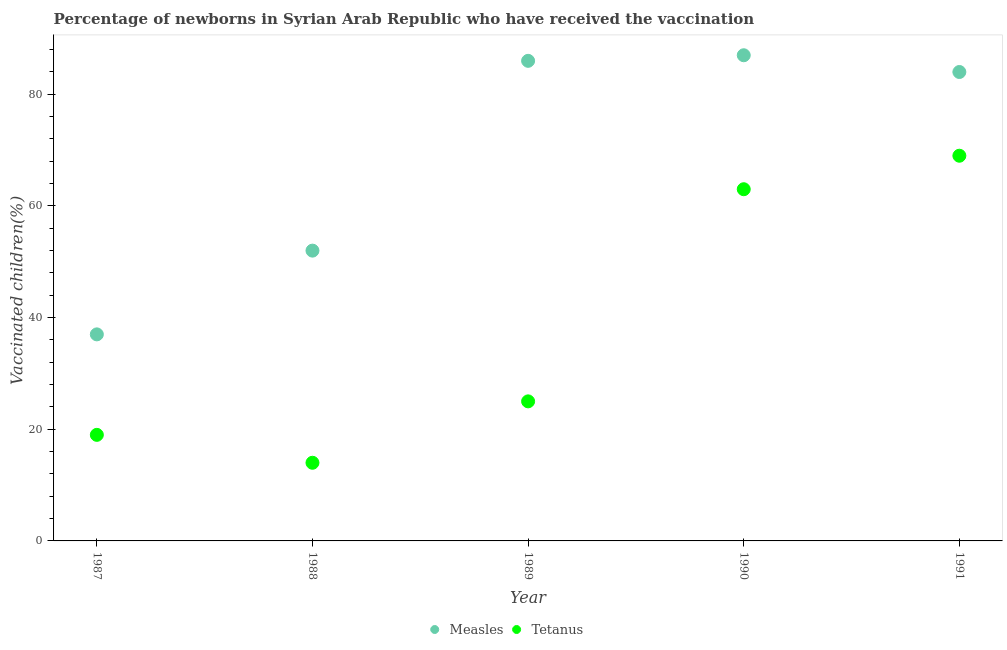Is the number of dotlines equal to the number of legend labels?
Make the answer very short. Yes. What is the percentage of newborns who received vaccination for tetanus in 1991?
Ensure brevity in your answer.  69. Across all years, what is the maximum percentage of newborns who received vaccination for measles?
Provide a succinct answer. 87. Across all years, what is the minimum percentage of newborns who received vaccination for tetanus?
Keep it short and to the point. 14. In which year was the percentage of newborns who received vaccination for measles maximum?
Give a very brief answer. 1990. In which year was the percentage of newborns who received vaccination for tetanus minimum?
Provide a short and direct response. 1988. What is the total percentage of newborns who received vaccination for tetanus in the graph?
Ensure brevity in your answer.  190. What is the difference between the percentage of newborns who received vaccination for measles in 1987 and that in 1990?
Provide a short and direct response. -50. What is the difference between the percentage of newborns who received vaccination for tetanus in 1988 and the percentage of newborns who received vaccination for measles in 1991?
Your answer should be compact. -70. What is the average percentage of newborns who received vaccination for measles per year?
Give a very brief answer. 69.2. In the year 1990, what is the difference between the percentage of newborns who received vaccination for tetanus and percentage of newborns who received vaccination for measles?
Give a very brief answer. -24. In how many years, is the percentage of newborns who received vaccination for tetanus greater than 32 %?
Your answer should be very brief. 2. What is the ratio of the percentage of newborns who received vaccination for measles in 1989 to that in 1991?
Your answer should be very brief. 1.02. Is the percentage of newborns who received vaccination for measles in 1987 less than that in 1988?
Your answer should be compact. Yes. What is the difference between the highest and the lowest percentage of newborns who received vaccination for tetanus?
Your response must be concise. 55. Does the percentage of newborns who received vaccination for tetanus monotonically increase over the years?
Provide a succinct answer. No. How many dotlines are there?
Offer a very short reply. 2. Does the graph contain any zero values?
Give a very brief answer. No. Does the graph contain grids?
Offer a very short reply. No. Where does the legend appear in the graph?
Your answer should be compact. Bottom center. What is the title of the graph?
Your answer should be compact. Percentage of newborns in Syrian Arab Republic who have received the vaccination. What is the label or title of the Y-axis?
Keep it short and to the point. Vaccinated children(%)
. What is the Vaccinated children(%)
 in Measles in 1987?
Your response must be concise. 37. What is the Vaccinated children(%)
 of Measles in 1988?
Provide a short and direct response. 52. What is the Vaccinated children(%)
 in Tetanus in 1988?
Keep it short and to the point. 14. What is the Vaccinated children(%)
 in Measles in 1989?
Keep it short and to the point. 86. What is the Vaccinated children(%)
 in Tetanus in 1989?
Offer a terse response. 25. What is the Vaccinated children(%)
 of Measles in 1990?
Your answer should be very brief. 87. What is the Vaccinated children(%)
 of Measles in 1991?
Offer a terse response. 84. What is the Vaccinated children(%)
 of Tetanus in 1991?
Offer a very short reply. 69. Across all years, what is the maximum Vaccinated children(%)
 of Measles?
Offer a terse response. 87. Across all years, what is the maximum Vaccinated children(%)
 of Tetanus?
Provide a short and direct response. 69. Across all years, what is the minimum Vaccinated children(%)
 of Measles?
Make the answer very short. 37. What is the total Vaccinated children(%)
 of Measles in the graph?
Keep it short and to the point. 346. What is the total Vaccinated children(%)
 in Tetanus in the graph?
Provide a short and direct response. 190. What is the difference between the Vaccinated children(%)
 of Measles in 1987 and that in 1989?
Offer a terse response. -49. What is the difference between the Vaccinated children(%)
 of Measles in 1987 and that in 1990?
Offer a terse response. -50. What is the difference between the Vaccinated children(%)
 in Tetanus in 1987 and that in 1990?
Make the answer very short. -44. What is the difference between the Vaccinated children(%)
 of Measles in 1987 and that in 1991?
Provide a short and direct response. -47. What is the difference between the Vaccinated children(%)
 in Tetanus in 1987 and that in 1991?
Give a very brief answer. -50. What is the difference between the Vaccinated children(%)
 of Measles in 1988 and that in 1989?
Your answer should be compact. -34. What is the difference between the Vaccinated children(%)
 of Tetanus in 1988 and that in 1989?
Offer a terse response. -11. What is the difference between the Vaccinated children(%)
 of Measles in 1988 and that in 1990?
Make the answer very short. -35. What is the difference between the Vaccinated children(%)
 of Tetanus in 1988 and that in 1990?
Your answer should be compact. -49. What is the difference between the Vaccinated children(%)
 of Measles in 1988 and that in 1991?
Provide a short and direct response. -32. What is the difference between the Vaccinated children(%)
 in Tetanus in 1988 and that in 1991?
Your answer should be very brief. -55. What is the difference between the Vaccinated children(%)
 of Measles in 1989 and that in 1990?
Ensure brevity in your answer.  -1. What is the difference between the Vaccinated children(%)
 of Tetanus in 1989 and that in 1990?
Keep it short and to the point. -38. What is the difference between the Vaccinated children(%)
 of Tetanus in 1989 and that in 1991?
Keep it short and to the point. -44. What is the difference between the Vaccinated children(%)
 in Measles in 1990 and that in 1991?
Your answer should be very brief. 3. What is the difference between the Vaccinated children(%)
 in Measles in 1987 and the Vaccinated children(%)
 in Tetanus in 1990?
Give a very brief answer. -26. What is the difference between the Vaccinated children(%)
 of Measles in 1987 and the Vaccinated children(%)
 of Tetanus in 1991?
Keep it short and to the point. -32. What is the difference between the Vaccinated children(%)
 of Measles in 1988 and the Vaccinated children(%)
 of Tetanus in 1990?
Ensure brevity in your answer.  -11. What is the difference between the Vaccinated children(%)
 of Measles in 1988 and the Vaccinated children(%)
 of Tetanus in 1991?
Give a very brief answer. -17. What is the difference between the Vaccinated children(%)
 in Measles in 1989 and the Vaccinated children(%)
 in Tetanus in 1991?
Offer a terse response. 17. What is the average Vaccinated children(%)
 of Measles per year?
Provide a short and direct response. 69.2. In the year 1988, what is the difference between the Vaccinated children(%)
 of Measles and Vaccinated children(%)
 of Tetanus?
Give a very brief answer. 38. What is the ratio of the Vaccinated children(%)
 of Measles in 1987 to that in 1988?
Offer a very short reply. 0.71. What is the ratio of the Vaccinated children(%)
 in Tetanus in 1987 to that in 1988?
Provide a short and direct response. 1.36. What is the ratio of the Vaccinated children(%)
 in Measles in 1987 to that in 1989?
Ensure brevity in your answer.  0.43. What is the ratio of the Vaccinated children(%)
 of Tetanus in 1987 to that in 1989?
Give a very brief answer. 0.76. What is the ratio of the Vaccinated children(%)
 in Measles in 1987 to that in 1990?
Offer a terse response. 0.43. What is the ratio of the Vaccinated children(%)
 of Tetanus in 1987 to that in 1990?
Keep it short and to the point. 0.3. What is the ratio of the Vaccinated children(%)
 of Measles in 1987 to that in 1991?
Make the answer very short. 0.44. What is the ratio of the Vaccinated children(%)
 in Tetanus in 1987 to that in 1991?
Keep it short and to the point. 0.28. What is the ratio of the Vaccinated children(%)
 in Measles in 1988 to that in 1989?
Provide a succinct answer. 0.6. What is the ratio of the Vaccinated children(%)
 in Tetanus in 1988 to that in 1989?
Your response must be concise. 0.56. What is the ratio of the Vaccinated children(%)
 of Measles in 1988 to that in 1990?
Your response must be concise. 0.6. What is the ratio of the Vaccinated children(%)
 in Tetanus in 1988 to that in 1990?
Your response must be concise. 0.22. What is the ratio of the Vaccinated children(%)
 of Measles in 1988 to that in 1991?
Make the answer very short. 0.62. What is the ratio of the Vaccinated children(%)
 in Tetanus in 1988 to that in 1991?
Your answer should be compact. 0.2. What is the ratio of the Vaccinated children(%)
 of Tetanus in 1989 to that in 1990?
Your response must be concise. 0.4. What is the ratio of the Vaccinated children(%)
 of Measles in 1989 to that in 1991?
Provide a short and direct response. 1.02. What is the ratio of the Vaccinated children(%)
 in Tetanus in 1989 to that in 1991?
Offer a very short reply. 0.36. What is the ratio of the Vaccinated children(%)
 of Measles in 1990 to that in 1991?
Your response must be concise. 1.04. What is the ratio of the Vaccinated children(%)
 in Tetanus in 1990 to that in 1991?
Your answer should be compact. 0.91. 